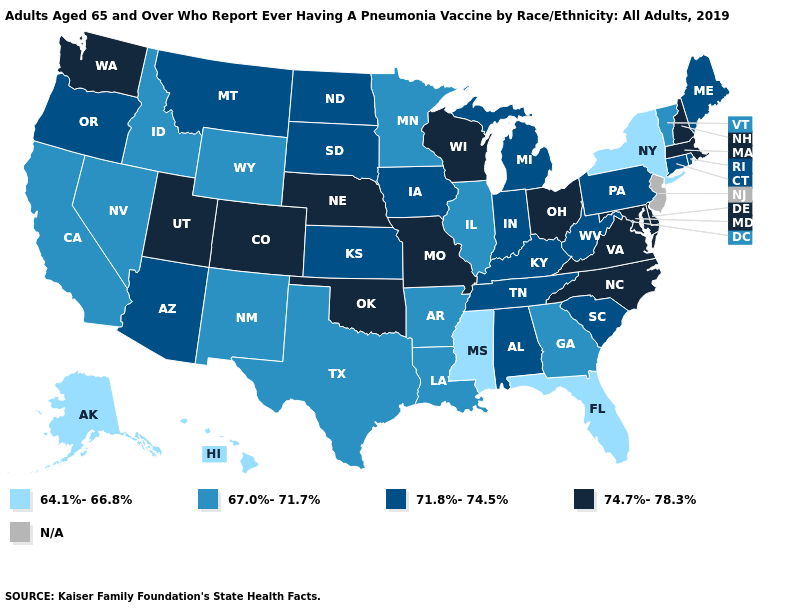What is the lowest value in the USA?
Short answer required. 64.1%-66.8%. What is the lowest value in the USA?
Be succinct. 64.1%-66.8%. What is the value of Wisconsin?
Short answer required. 74.7%-78.3%. What is the value of Mississippi?
Write a very short answer. 64.1%-66.8%. Does the map have missing data?
Write a very short answer. Yes. Which states have the lowest value in the West?
Concise answer only. Alaska, Hawaii. Name the states that have a value in the range 71.8%-74.5%?
Give a very brief answer. Alabama, Arizona, Connecticut, Indiana, Iowa, Kansas, Kentucky, Maine, Michigan, Montana, North Dakota, Oregon, Pennsylvania, Rhode Island, South Carolina, South Dakota, Tennessee, West Virginia. Name the states that have a value in the range N/A?
Short answer required. New Jersey. Name the states that have a value in the range 64.1%-66.8%?
Give a very brief answer. Alaska, Florida, Hawaii, Mississippi, New York. What is the value of Idaho?
Be succinct. 67.0%-71.7%. Which states have the highest value in the USA?
Quick response, please. Colorado, Delaware, Maryland, Massachusetts, Missouri, Nebraska, New Hampshire, North Carolina, Ohio, Oklahoma, Utah, Virginia, Washington, Wisconsin. Name the states that have a value in the range 64.1%-66.8%?
Quick response, please. Alaska, Florida, Hawaii, Mississippi, New York. 